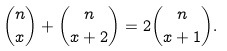<formula> <loc_0><loc_0><loc_500><loc_500>\binom { n } { x } + \binom { n } { x + 2 } = 2 \binom { n } { x + 1 } .</formula> 